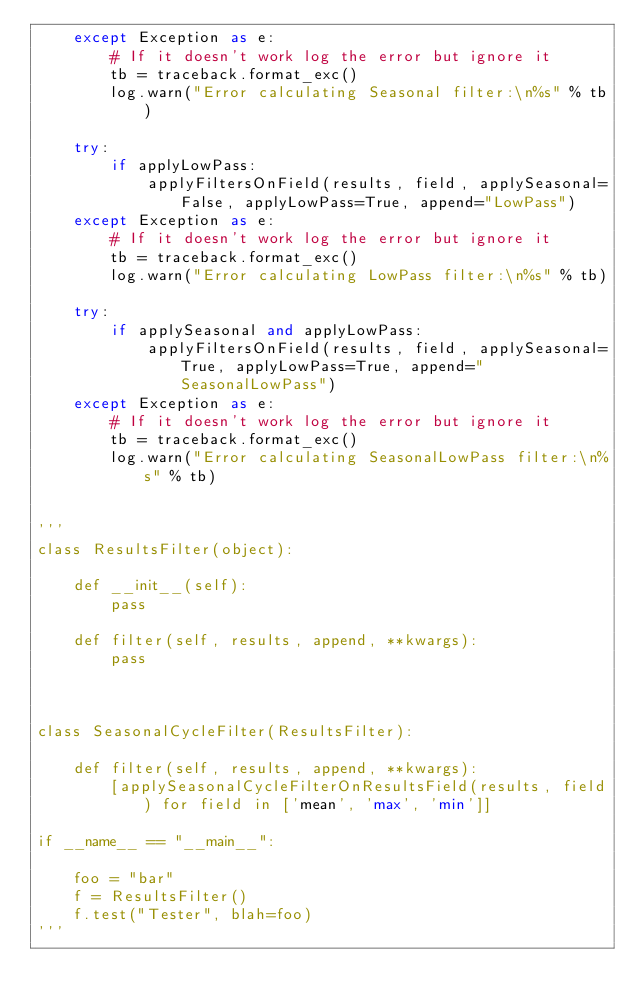Convert code to text. <code><loc_0><loc_0><loc_500><loc_500><_Python_>    except Exception as e:
        # If it doesn't work log the error but ignore it
        tb = traceback.format_exc()
        log.warn("Error calculating Seasonal filter:\n%s" % tb)

    try:
        if applyLowPass:
            applyFiltersOnField(results, field, applySeasonal=False, applyLowPass=True, append="LowPass")
    except Exception as e:
        # If it doesn't work log the error but ignore it
        tb = traceback.format_exc()
        log.warn("Error calculating LowPass filter:\n%s" % tb)

    try:
        if applySeasonal and applyLowPass:
            applyFiltersOnField(results, field, applySeasonal=True, applyLowPass=True, append="SeasonalLowPass")
    except Exception as e:
        # If it doesn't work log the error but ignore it
        tb = traceback.format_exc()
        log.warn("Error calculating SeasonalLowPass filter:\n%s" % tb)


'''
class ResultsFilter(object):

    def __init__(self):
        pass

    def filter(self, results, append, **kwargs):
        pass



class SeasonalCycleFilter(ResultsFilter):

    def filter(self, results, append, **kwargs):
        [applySeasonalCycleFilterOnResultsField(results, field) for field in ['mean', 'max', 'min']]

if __name__ == "__main__":

    foo = "bar"
    f = ResultsFilter()
    f.test("Tester", blah=foo)
'''
</code> 